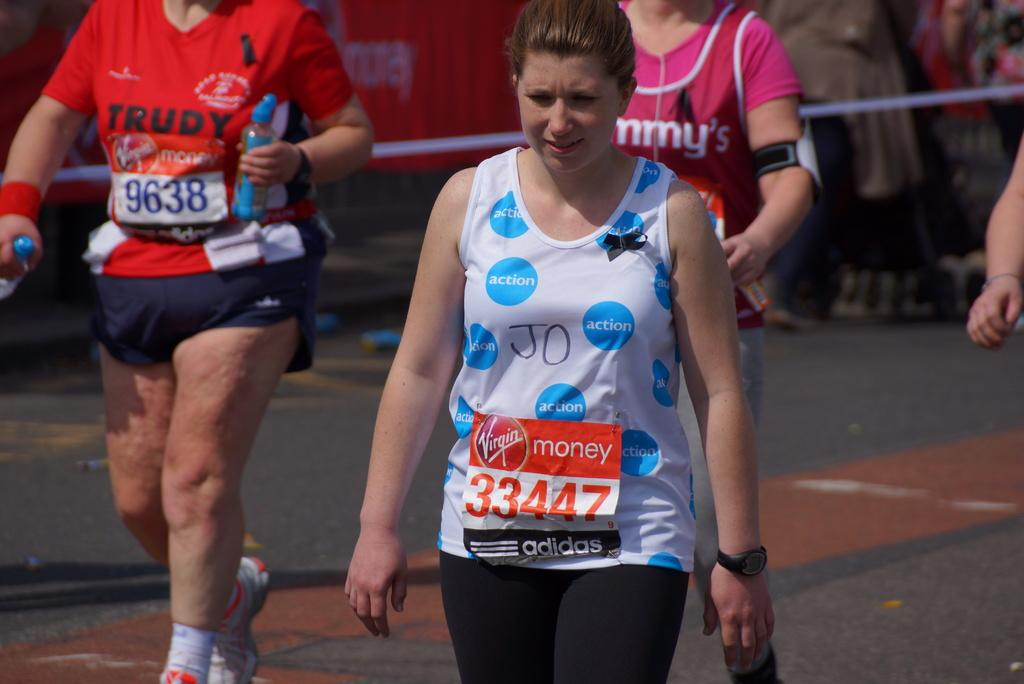Provide a one-sentence caption for the provided image. A running sign that says Virgin money 33447 adidas. 